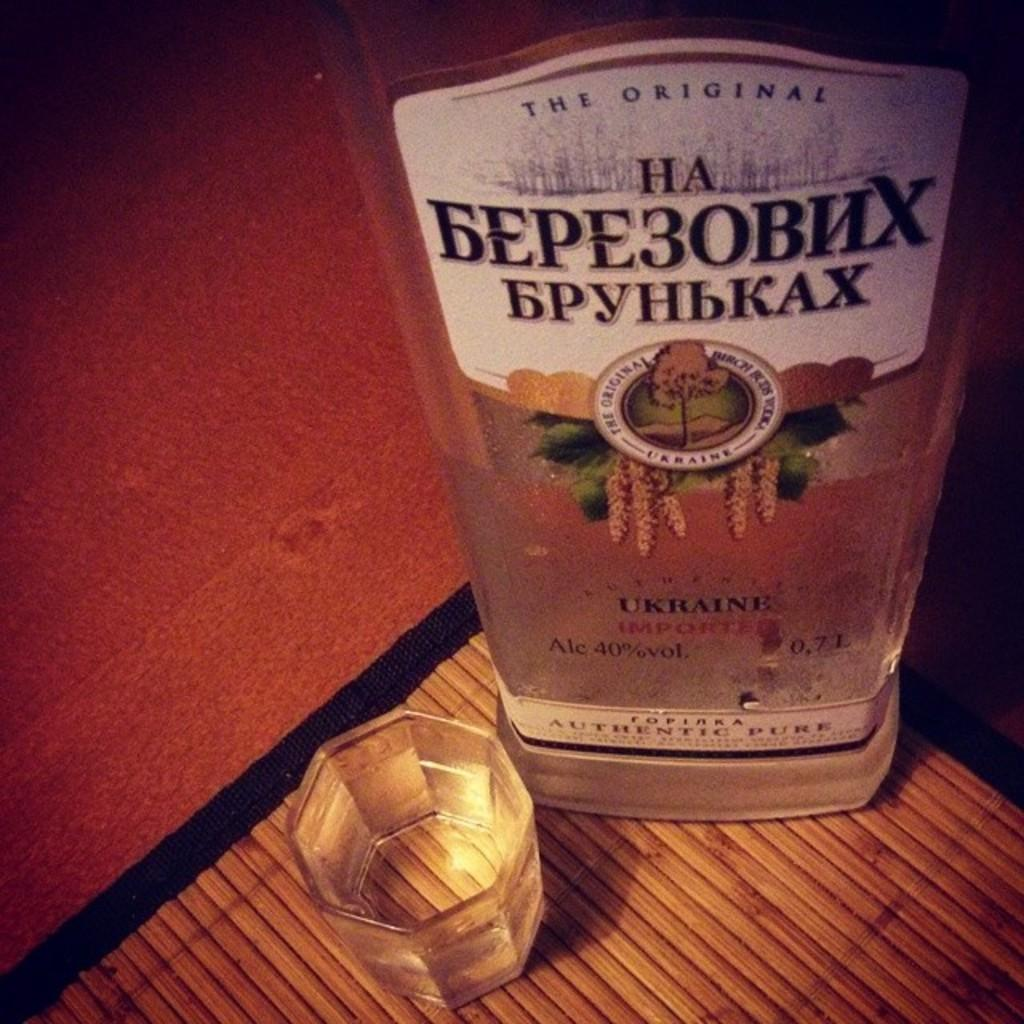<image>
Provide a brief description of the given image. a bottle of the original ha bepe3obhx bpyhbkax 